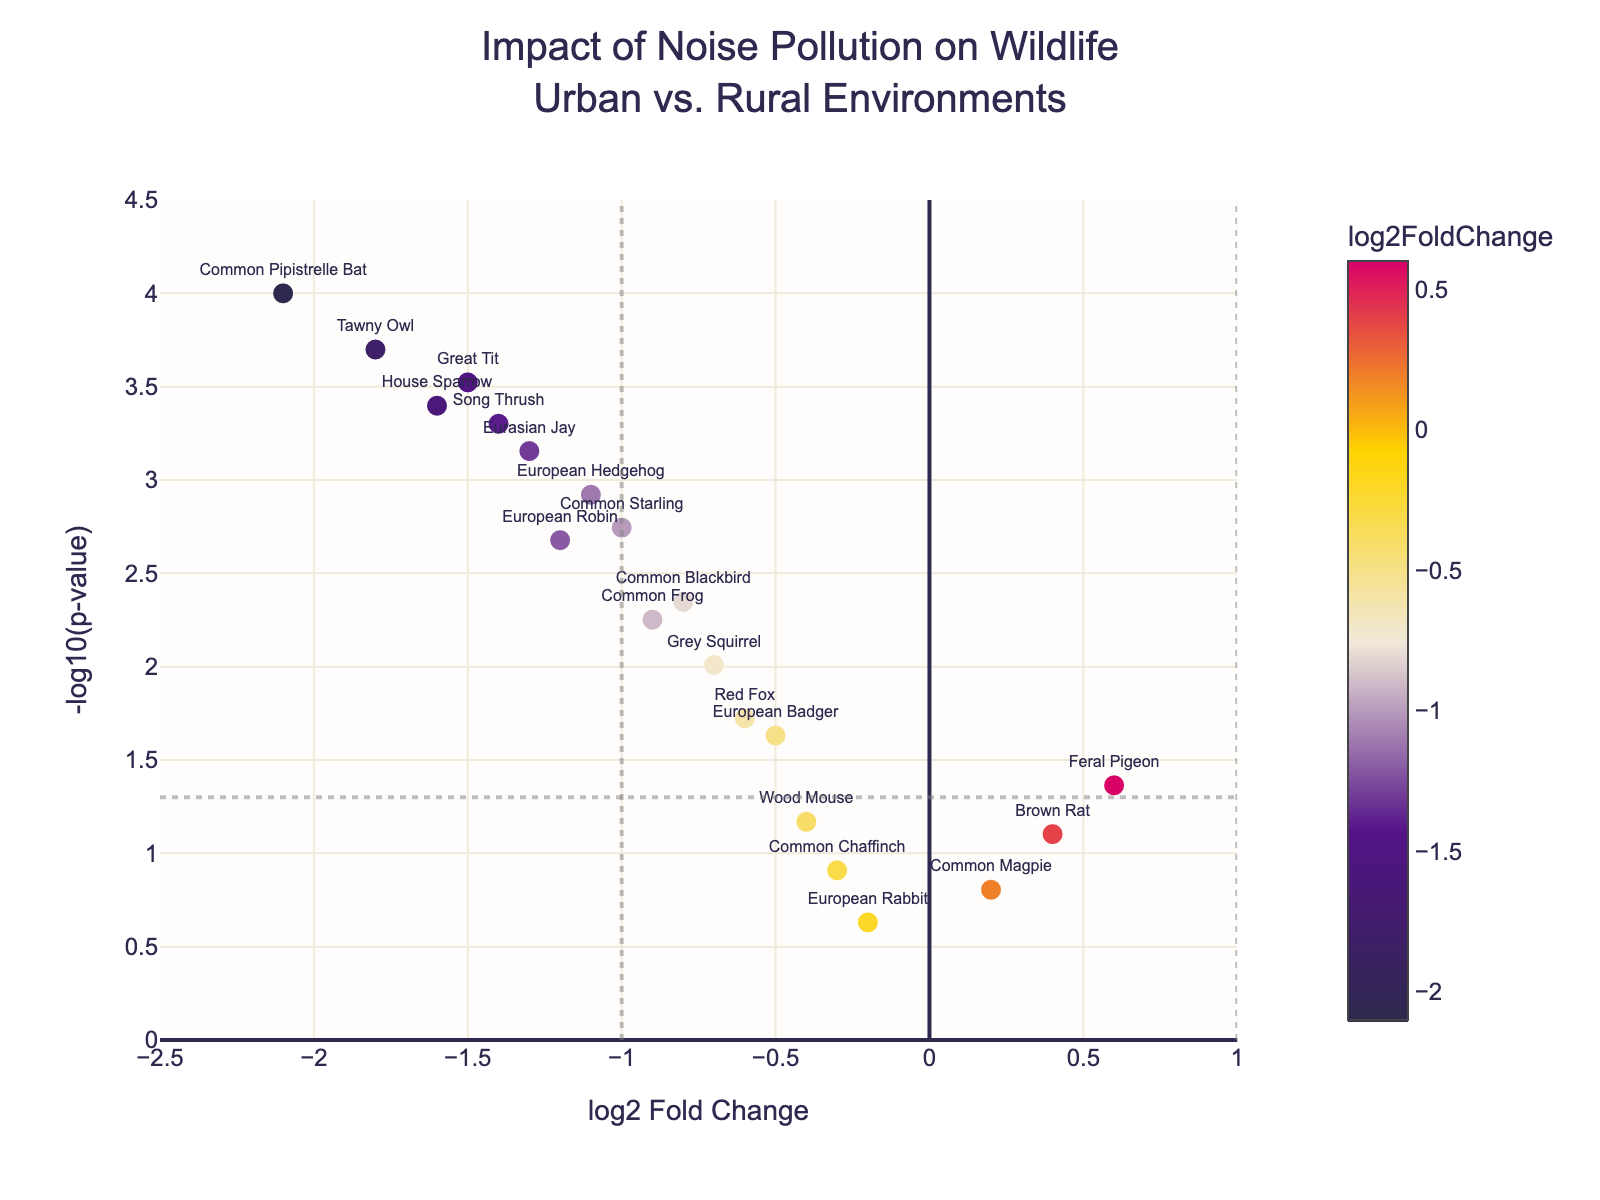How many species are shown in the plot? To determine the number of species, count the unique data points marked with labels on the plot. Each point represents one species.
Answer: 19 What does the x-axis represent? The x-axis represents the log2 Fold Change, which indicates whether the species' activity is suppressed or enhanced due to noise pollution, with negative values showing suppression and positive values showing enhancement.
Answer: log2 Fold Change What is the significance threshold for the p-value marked on the plot? The significance threshold for the p-value is often marked by a horizontal line. In this plot, a line is drawn at y = -log10(0.05), which signifies the p-value threshold of 0.05.
Answer: 0.05 Which species is the most significantly affected by noise pollution according to the plot? To find the most significantly affected species, look for the data point with the highest -log10(p-value). In the plot, this species is the Common Pipistrelle Bat.
Answer: Common Pipistrelle Bat How many species have a log2 Fold Change of less than -1? Count the number of data points to the left of the vertical line at x = -1. These species have a log2 Fold Change less than -1.
Answer: 7 Which species has the highest positive log2 Fold Change, and what is its corresponding p-value? To find this, locate the data point with the highest positive log2 Fold Change on the x-axis. This species is the Feral Pigeon, and its corresponding p-value is annotated in the hovertext or can be referenced from the dataset.
Answer: Feral Pigeon, 0.0432 What can you infer about the species with a log2 Fold Change close to zero? Species with a log2 Fold Change close to zero are not significantly affected (either suppressed or enhanced) by noise pollution. In this plot, the European Rabbit and Common Magpie fall close to this category.
Answer: Not significantly affected Which species are found to be statistically significant with a p-value less than 0.05? The species below the horizontal line at y = -log10(0.05) have a p-value less than 0.05. These include European Robin, Common Blackbird, Great Tit, European Hedgehog, Common Pipistrelle Bat, Tawny Owl, Eurasian Jay, Common Starling, House Sparrow, Song Thrush, and Grey Squirrel.
Answer: 11 species What is the -log10(p-value) for the Song Thrush, and how does it compare to the Tawny Owl? The -log10(p-value) for Song Thrush can be found by looking at its vertical position on the plot. Similarly, find the Tawny Owl's position. Compare the two values to determine their relationship.
Answer: Song Thrush: ~3.3, Tawny Owl: ~3.7; Tawny Owl's -log10(p-value) is higher than Song Thrush How is the color scale used in the plot, and what does it signify? The color scale varies from dark blue for lower log2 Fold Change values to bright red for higher values. It indicates the degree of log2 Fold Change, with more intense colors representing more extreme values.
Answer: Reflects log2 Fold Change 